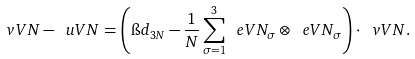Convert formula to latex. <formula><loc_0><loc_0><loc_500><loc_500>\ v V N - \ u V N = \left ( \i d _ { 3 N } - \frac { 1 } { N } \sum _ { \sigma = 1 } ^ { 3 } \ e V N _ { \sigma } \otimes \ e V N _ { \sigma } \right ) \cdot \ v V N .</formula> 